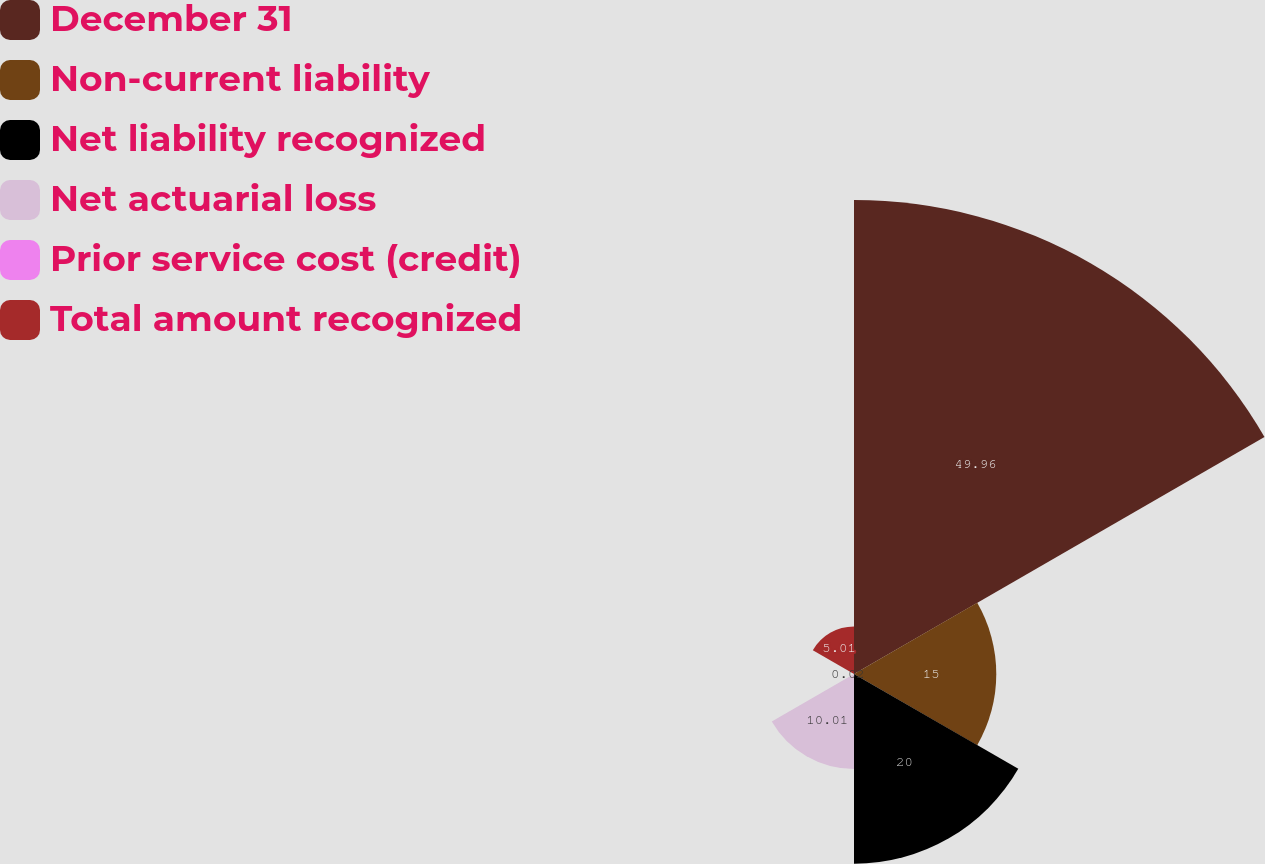<chart> <loc_0><loc_0><loc_500><loc_500><pie_chart><fcel>December 31<fcel>Non-current liability<fcel>Net liability recognized<fcel>Net actuarial loss<fcel>Prior service cost (credit)<fcel>Total amount recognized<nl><fcel>49.97%<fcel>15.0%<fcel>20.0%<fcel>10.01%<fcel>0.02%<fcel>5.01%<nl></chart> 